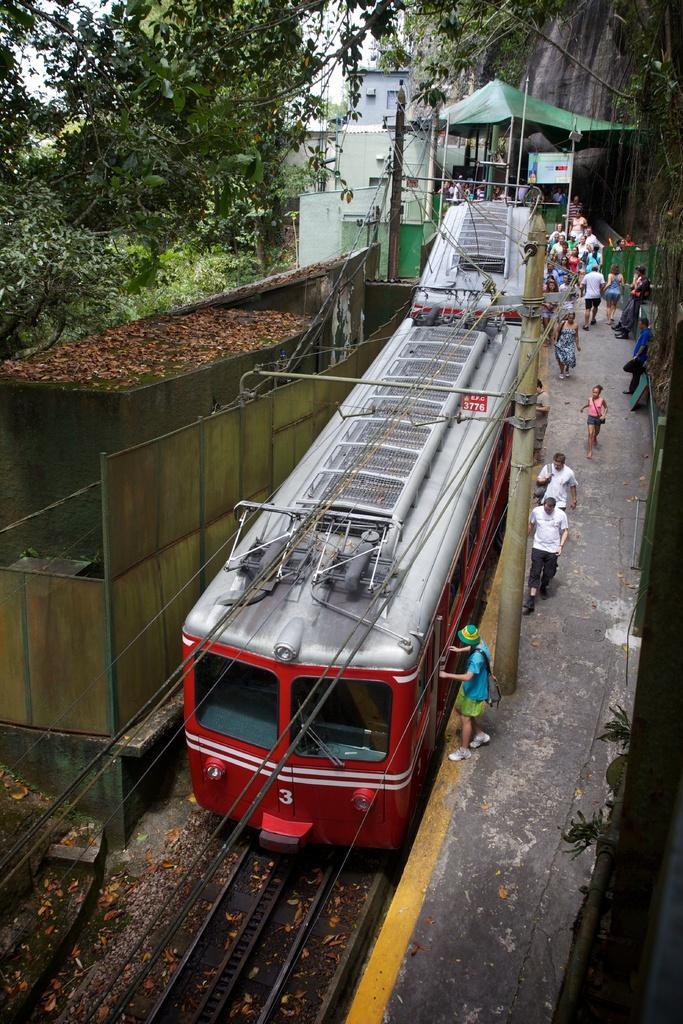How would you summarize this image in a sentence or two? In this image we can see a train. There are many trees and plants in the image. There are many people in the image. There is an electrical pole and a few cables are connected to it. 